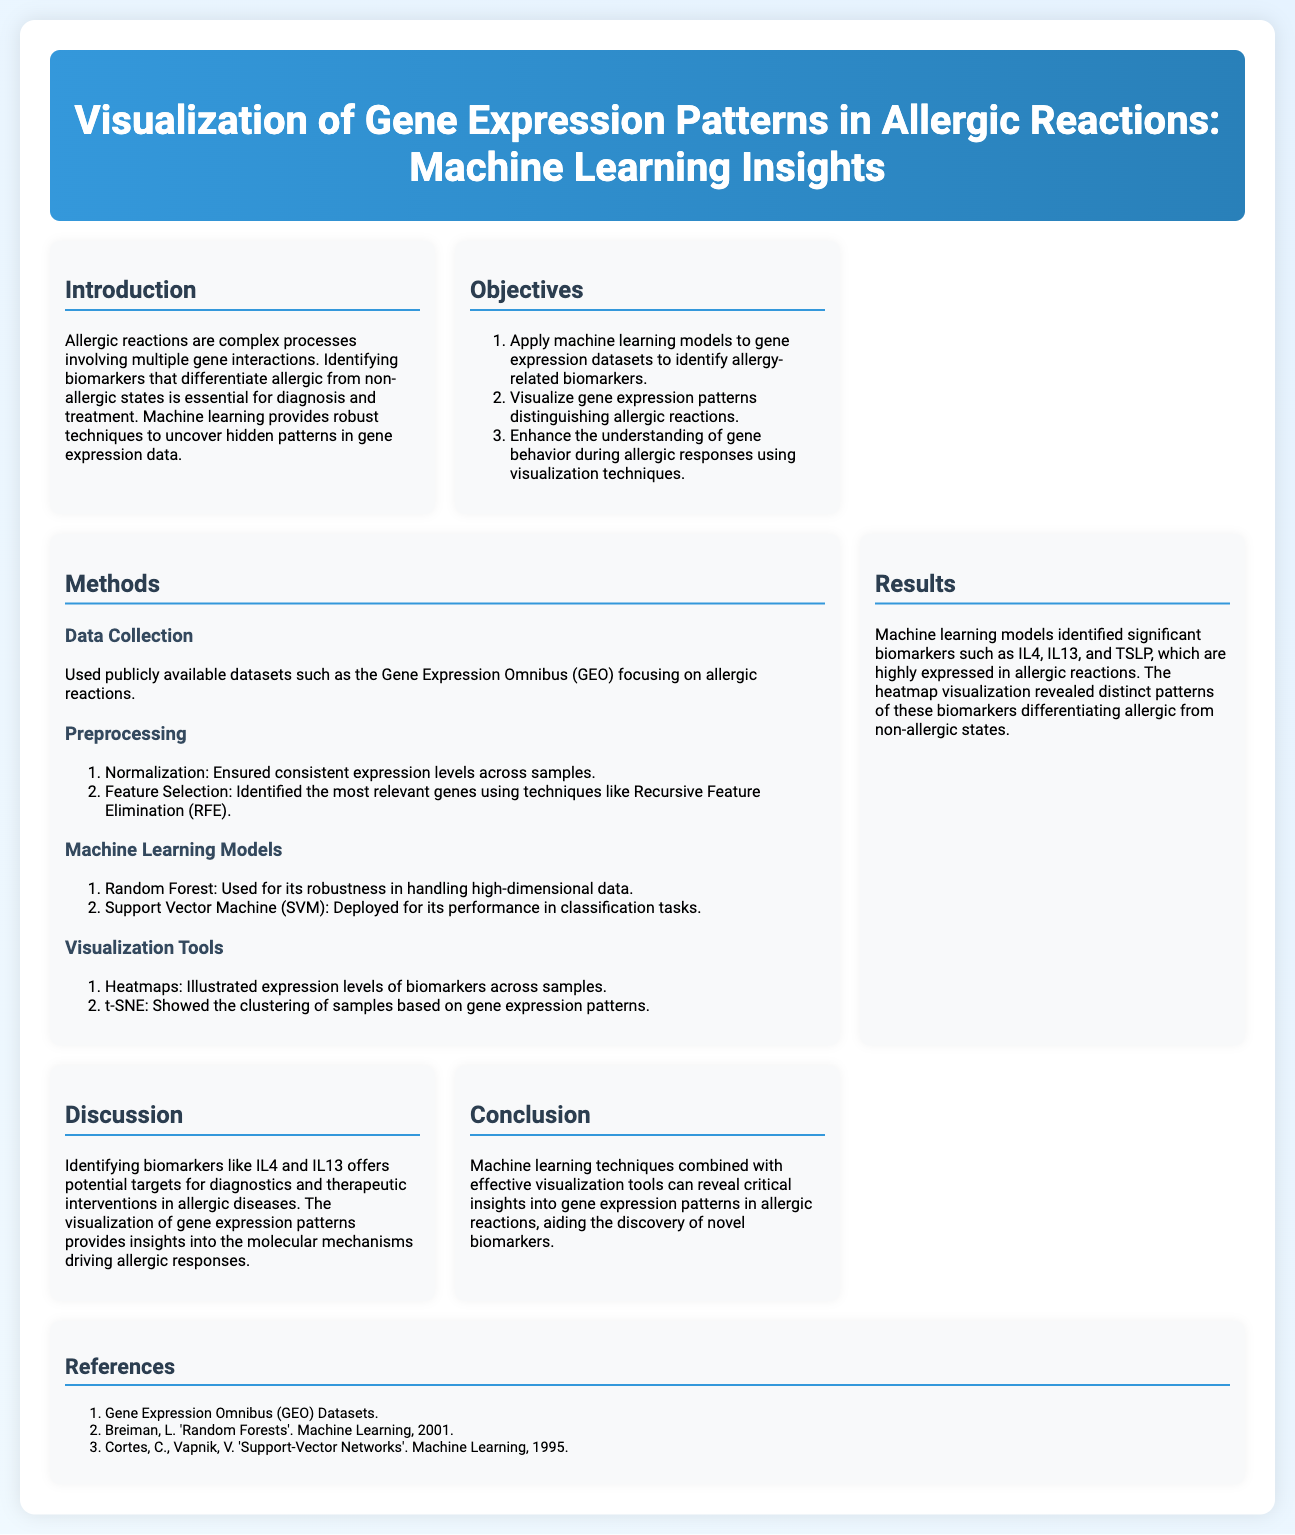what is the title of the poster? The title of the poster is presented prominently at the top and encapsulates the study's focus on gene expression and machine learning related to allergies.
Answer: Visualization of Gene Expression Patterns in Allergic Reactions: Machine Learning Insights how many objectives are listed in the poster? The poster outlines a specific number of objectives within the Objectives section.
Answer: 3 which datasets were used for data collection? The Data Collection section specifies the source of datasets utilized for the study.
Answer: Gene Expression Omnibus (GEO) name one of the biomarkers identified in allergic reactions. The Results section highlights significant biomarkers found through machine learning techniques related to allergies.
Answer: IL4 what visualization tool illustrates the expression levels of biomarkers? The Methods section mentions specific visualization tools employed for displaying gene expression data.
Answer: Heatmaps which two machine learning models were applied in the study? The Methods section outlines the specific machine learning models that were utilized in the analysis of gene expression data.
Answer: Random Forest and Support Vector Machine (SVM) what is one key insight gained from the discussion section? The Discussion section summarizes key findings and implications of the study, providing insights into biomarkers and genetic mechanisms.
Answer: potential targets for diagnostics and therapeutic interventions in allergic diseases how does the poster conclude about machine learning and visualization tools? The conclusion emphasizes the overall contribution of the methods used to the field of allergy research.
Answer: reveal critical insights into gene expression patterns in allergic reactions 